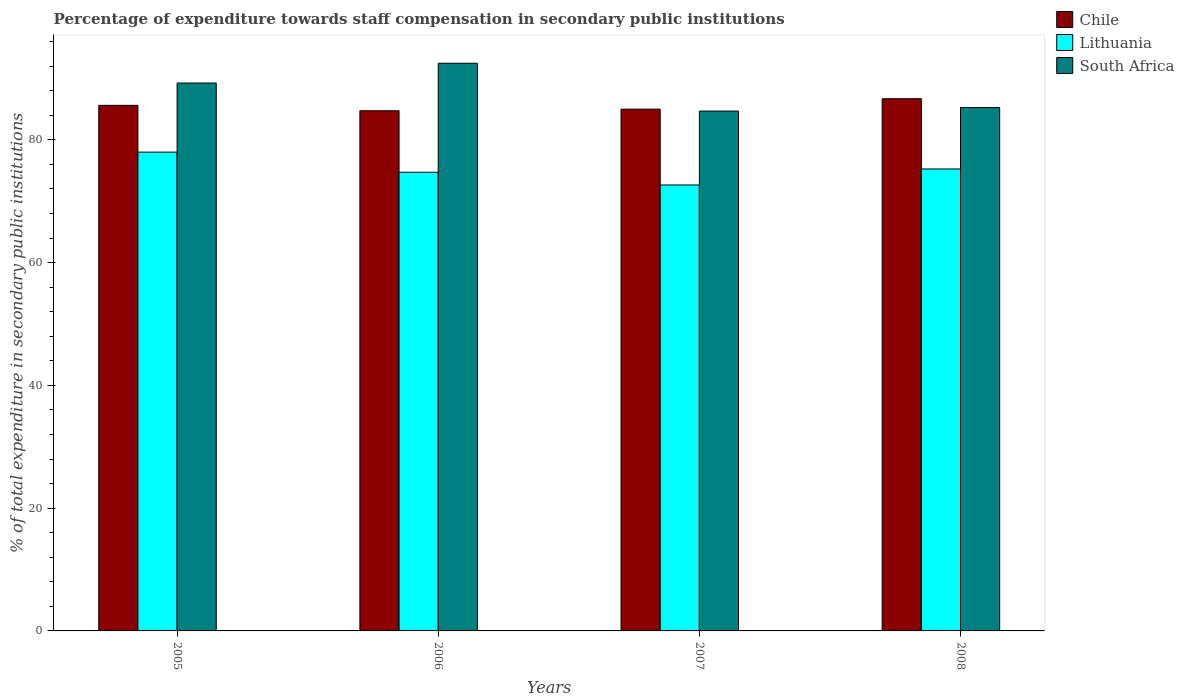Are the number of bars on each tick of the X-axis equal?
Offer a terse response. Yes. How many bars are there on the 3rd tick from the left?
Offer a terse response. 3. In how many cases, is the number of bars for a given year not equal to the number of legend labels?
Keep it short and to the point. 0. What is the percentage of expenditure towards staff compensation in South Africa in 2005?
Offer a very short reply. 89.25. Across all years, what is the maximum percentage of expenditure towards staff compensation in South Africa?
Ensure brevity in your answer.  92.47. Across all years, what is the minimum percentage of expenditure towards staff compensation in South Africa?
Your answer should be compact. 84.68. In which year was the percentage of expenditure towards staff compensation in Chile minimum?
Offer a very short reply. 2006. What is the total percentage of expenditure towards staff compensation in South Africa in the graph?
Give a very brief answer. 351.65. What is the difference between the percentage of expenditure towards staff compensation in Lithuania in 2005 and that in 2006?
Keep it short and to the point. 3.28. What is the difference between the percentage of expenditure towards staff compensation in Lithuania in 2008 and the percentage of expenditure towards staff compensation in Chile in 2005?
Offer a very short reply. -10.36. What is the average percentage of expenditure towards staff compensation in South Africa per year?
Offer a very short reply. 87.91. In the year 2005, what is the difference between the percentage of expenditure towards staff compensation in Lithuania and percentage of expenditure towards staff compensation in South Africa?
Keep it short and to the point. -11.26. What is the ratio of the percentage of expenditure towards staff compensation in Chile in 2006 to that in 2007?
Offer a very short reply. 1. Is the difference between the percentage of expenditure towards staff compensation in Lithuania in 2006 and 2008 greater than the difference between the percentage of expenditure towards staff compensation in South Africa in 2006 and 2008?
Your answer should be compact. No. What is the difference between the highest and the second highest percentage of expenditure towards staff compensation in Lithuania?
Make the answer very short. 2.74. What is the difference between the highest and the lowest percentage of expenditure towards staff compensation in Lithuania?
Provide a short and direct response. 5.35. In how many years, is the percentage of expenditure towards staff compensation in South Africa greater than the average percentage of expenditure towards staff compensation in South Africa taken over all years?
Your response must be concise. 2. Is the sum of the percentage of expenditure towards staff compensation in South Africa in 2005 and 2006 greater than the maximum percentage of expenditure towards staff compensation in Chile across all years?
Offer a very short reply. Yes. What does the 2nd bar from the left in 2008 represents?
Your answer should be compact. Lithuania. What does the 1st bar from the right in 2008 represents?
Your answer should be very brief. South Africa. How many bars are there?
Provide a succinct answer. 12. Are all the bars in the graph horizontal?
Ensure brevity in your answer.  No. What is the difference between two consecutive major ticks on the Y-axis?
Ensure brevity in your answer.  20. Does the graph contain any zero values?
Keep it short and to the point. No. Where does the legend appear in the graph?
Ensure brevity in your answer.  Top right. What is the title of the graph?
Offer a very short reply. Percentage of expenditure towards staff compensation in secondary public institutions. Does "Papua New Guinea" appear as one of the legend labels in the graph?
Offer a very short reply. No. What is the label or title of the X-axis?
Make the answer very short. Years. What is the label or title of the Y-axis?
Offer a very short reply. % of total expenditure in secondary public institutions. What is the % of total expenditure in secondary public institutions of Chile in 2005?
Your response must be concise. 85.61. What is the % of total expenditure in secondary public institutions of Lithuania in 2005?
Give a very brief answer. 77.99. What is the % of total expenditure in secondary public institutions of South Africa in 2005?
Give a very brief answer. 89.25. What is the % of total expenditure in secondary public institutions of Chile in 2006?
Provide a short and direct response. 84.73. What is the % of total expenditure in secondary public institutions in Lithuania in 2006?
Your answer should be very brief. 74.71. What is the % of total expenditure in secondary public institutions of South Africa in 2006?
Keep it short and to the point. 92.47. What is the % of total expenditure in secondary public institutions in Chile in 2007?
Provide a succinct answer. 84.99. What is the % of total expenditure in secondary public institutions of Lithuania in 2007?
Give a very brief answer. 72.64. What is the % of total expenditure in secondary public institutions of South Africa in 2007?
Give a very brief answer. 84.68. What is the % of total expenditure in secondary public institutions in Chile in 2008?
Provide a short and direct response. 86.69. What is the % of total expenditure in secondary public institutions of Lithuania in 2008?
Give a very brief answer. 75.25. What is the % of total expenditure in secondary public institutions in South Africa in 2008?
Your answer should be very brief. 85.25. Across all years, what is the maximum % of total expenditure in secondary public institutions of Chile?
Make the answer very short. 86.69. Across all years, what is the maximum % of total expenditure in secondary public institutions in Lithuania?
Provide a succinct answer. 77.99. Across all years, what is the maximum % of total expenditure in secondary public institutions of South Africa?
Give a very brief answer. 92.47. Across all years, what is the minimum % of total expenditure in secondary public institutions in Chile?
Your answer should be very brief. 84.73. Across all years, what is the minimum % of total expenditure in secondary public institutions of Lithuania?
Provide a succinct answer. 72.64. Across all years, what is the minimum % of total expenditure in secondary public institutions in South Africa?
Your answer should be compact. 84.68. What is the total % of total expenditure in secondary public institutions in Chile in the graph?
Offer a terse response. 342.03. What is the total % of total expenditure in secondary public institutions in Lithuania in the graph?
Offer a very short reply. 300.6. What is the total % of total expenditure in secondary public institutions of South Africa in the graph?
Keep it short and to the point. 351.65. What is the difference between the % of total expenditure in secondary public institutions of Chile in 2005 and that in 2006?
Your answer should be compact. 0.88. What is the difference between the % of total expenditure in secondary public institutions of Lithuania in 2005 and that in 2006?
Offer a terse response. 3.28. What is the difference between the % of total expenditure in secondary public institutions in South Africa in 2005 and that in 2006?
Make the answer very short. -3.22. What is the difference between the % of total expenditure in secondary public institutions of Chile in 2005 and that in 2007?
Give a very brief answer. 0.62. What is the difference between the % of total expenditure in secondary public institutions of Lithuania in 2005 and that in 2007?
Offer a terse response. 5.35. What is the difference between the % of total expenditure in secondary public institutions of South Africa in 2005 and that in 2007?
Provide a succinct answer. 4.57. What is the difference between the % of total expenditure in secondary public institutions of Chile in 2005 and that in 2008?
Offer a very short reply. -1.08. What is the difference between the % of total expenditure in secondary public institutions of Lithuania in 2005 and that in 2008?
Your response must be concise. 2.74. What is the difference between the % of total expenditure in secondary public institutions of South Africa in 2005 and that in 2008?
Keep it short and to the point. 4. What is the difference between the % of total expenditure in secondary public institutions of Chile in 2006 and that in 2007?
Your answer should be very brief. -0.26. What is the difference between the % of total expenditure in secondary public institutions of Lithuania in 2006 and that in 2007?
Make the answer very short. 2.07. What is the difference between the % of total expenditure in secondary public institutions of South Africa in 2006 and that in 2007?
Your answer should be very brief. 7.79. What is the difference between the % of total expenditure in secondary public institutions in Chile in 2006 and that in 2008?
Your answer should be very brief. -1.96. What is the difference between the % of total expenditure in secondary public institutions in Lithuania in 2006 and that in 2008?
Offer a terse response. -0.54. What is the difference between the % of total expenditure in secondary public institutions of South Africa in 2006 and that in 2008?
Keep it short and to the point. 7.22. What is the difference between the % of total expenditure in secondary public institutions of Chile in 2007 and that in 2008?
Your answer should be compact. -1.7. What is the difference between the % of total expenditure in secondary public institutions in Lithuania in 2007 and that in 2008?
Your answer should be compact. -2.61. What is the difference between the % of total expenditure in secondary public institutions of South Africa in 2007 and that in 2008?
Your answer should be very brief. -0.57. What is the difference between the % of total expenditure in secondary public institutions in Chile in 2005 and the % of total expenditure in secondary public institutions in Lithuania in 2006?
Your answer should be compact. 10.9. What is the difference between the % of total expenditure in secondary public institutions in Chile in 2005 and the % of total expenditure in secondary public institutions in South Africa in 2006?
Your response must be concise. -6.86. What is the difference between the % of total expenditure in secondary public institutions of Lithuania in 2005 and the % of total expenditure in secondary public institutions of South Africa in 2006?
Ensure brevity in your answer.  -14.47. What is the difference between the % of total expenditure in secondary public institutions of Chile in 2005 and the % of total expenditure in secondary public institutions of Lithuania in 2007?
Ensure brevity in your answer.  12.97. What is the difference between the % of total expenditure in secondary public institutions in Chile in 2005 and the % of total expenditure in secondary public institutions in South Africa in 2007?
Make the answer very short. 0.93. What is the difference between the % of total expenditure in secondary public institutions of Lithuania in 2005 and the % of total expenditure in secondary public institutions of South Africa in 2007?
Ensure brevity in your answer.  -6.69. What is the difference between the % of total expenditure in secondary public institutions in Chile in 2005 and the % of total expenditure in secondary public institutions in Lithuania in 2008?
Ensure brevity in your answer.  10.36. What is the difference between the % of total expenditure in secondary public institutions in Chile in 2005 and the % of total expenditure in secondary public institutions in South Africa in 2008?
Make the answer very short. 0.36. What is the difference between the % of total expenditure in secondary public institutions in Lithuania in 2005 and the % of total expenditure in secondary public institutions in South Africa in 2008?
Your answer should be very brief. -7.26. What is the difference between the % of total expenditure in secondary public institutions of Chile in 2006 and the % of total expenditure in secondary public institutions of Lithuania in 2007?
Ensure brevity in your answer.  12.09. What is the difference between the % of total expenditure in secondary public institutions of Chile in 2006 and the % of total expenditure in secondary public institutions of South Africa in 2007?
Your response must be concise. 0.05. What is the difference between the % of total expenditure in secondary public institutions of Lithuania in 2006 and the % of total expenditure in secondary public institutions of South Africa in 2007?
Provide a short and direct response. -9.97. What is the difference between the % of total expenditure in secondary public institutions of Chile in 2006 and the % of total expenditure in secondary public institutions of Lithuania in 2008?
Keep it short and to the point. 9.48. What is the difference between the % of total expenditure in secondary public institutions of Chile in 2006 and the % of total expenditure in secondary public institutions of South Africa in 2008?
Offer a very short reply. -0.52. What is the difference between the % of total expenditure in secondary public institutions in Lithuania in 2006 and the % of total expenditure in secondary public institutions in South Africa in 2008?
Make the answer very short. -10.54. What is the difference between the % of total expenditure in secondary public institutions in Chile in 2007 and the % of total expenditure in secondary public institutions in Lithuania in 2008?
Make the answer very short. 9.74. What is the difference between the % of total expenditure in secondary public institutions of Chile in 2007 and the % of total expenditure in secondary public institutions of South Africa in 2008?
Ensure brevity in your answer.  -0.26. What is the difference between the % of total expenditure in secondary public institutions of Lithuania in 2007 and the % of total expenditure in secondary public institutions of South Africa in 2008?
Ensure brevity in your answer.  -12.61. What is the average % of total expenditure in secondary public institutions in Chile per year?
Offer a very short reply. 85.51. What is the average % of total expenditure in secondary public institutions of Lithuania per year?
Your answer should be compact. 75.15. What is the average % of total expenditure in secondary public institutions of South Africa per year?
Make the answer very short. 87.91. In the year 2005, what is the difference between the % of total expenditure in secondary public institutions of Chile and % of total expenditure in secondary public institutions of Lithuania?
Keep it short and to the point. 7.62. In the year 2005, what is the difference between the % of total expenditure in secondary public institutions of Chile and % of total expenditure in secondary public institutions of South Africa?
Provide a short and direct response. -3.64. In the year 2005, what is the difference between the % of total expenditure in secondary public institutions in Lithuania and % of total expenditure in secondary public institutions in South Africa?
Your response must be concise. -11.26. In the year 2006, what is the difference between the % of total expenditure in secondary public institutions in Chile and % of total expenditure in secondary public institutions in Lithuania?
Make the answer very short. 10.02. In the year 2006, what is the difference between the % of total expenditure in secondary public institutions of Chile and % of total expenditure in secondary public institutions of South Africa?
Provide a short and direct response. -7.74. In the year 2006, what is the difference between the % of total expenditure in secondary public institutions in Lithuania and % of total expenditure in secondary public institutions in South Africa?
Your answer should be very brief. -17.75. In the year 2007, what is the difference between the % of total expenditure in secondary public institutions of Chile and % of total expenditure in secondary public institutions of Lithuania?
Your answer should be compact. 12.35. In the year 2007, what is the difference between the % of total expenditure in secondary public institutions in Chile and % of total expenditure in secondary public institutions in South Africa?
Make the answer very short. 0.31. In the year 2007, what is the difference between the % of total expenditure in secondary public institutions of Lithuania and % of total expenditure in secondary public institutions of South Africa?
Your response must be concise. -12.04. In the year 2008, what is the difference between the % of total expenditure in secondary public institutions in Chile and % of total expenditure in secondary public institutions in Lithuania?
Make the answer very short. 11.44. In the year 2008, what is the difference between the % of total expenditure in secondary public institutions in Chile and % of total expenditure in secondary public institutions in South Africa?
Offer a terse response. 1.44. In the year 2008, what is the difference between the % of total expenditure in secondary public institutions of Lithuania and % of total expenditure in secondary public institutions of South Africa?
Provide a short and direct response. -10. What is the ratio of the % of total expenditure in secondary public institutions in Chile in 2005 to that in 2006?
Offer a terse response. 1.01. What is the ratio of the % of total expenditure in secondary public institutions of Lithuania in 2005 to that in 2006?
Offer a very short reply. 1.04. What is the ratio of the % of total expenditure in secondary public institutions of South Africa in 2005 to that in 2006?
Ensure brevity in your answer.  0.97. What is the ratio of the % of total expenditure in secondary public institutions of Chile in 2005 to that in 2007?
Provide a short and direct response. 1.01. What is the ratio of the % of total expenditure in secondary public institutions of Lithuania in 2005 to that in 2007?
Ensure brevity in your answer.  1.07. What is the ratio of the % of total expenditure in secondary public institutions of South Africa in 2005 to that in 2007?
Give a very brief answer. 1.05. What is the ratio of the % of total expenditure in secondary public institutions in Chile in 2005 to that in 2008?
Offer a terse response. 0.99. What is the ratio of the % of total expenditure in secondary public institutions of Lithuania in 2005 to that in 2008?
Provide a succinct answer. 1.04. What is the ratio of the % of total expenditure in secondary public institutions of South Africa in 2005 to that in 2008?
Your response must be concise. 1.05. What is the ratio of the % of total expenditure in secondary public institutions of Lithuania in 2006 to that in 2007?
Give a very brief answer. 1.03. What is the ratio of the % of total expenditure in secondary public institutions in South Africa in 2006 to that in 2007?
Make the answer very short. 1.09. What is the ratio of the % of total expenditure in secondary public institutions in Chile in 2006 to that in 2008?
Ensure brevity in your answer.  0.98. What is the ratio of the % of total expenditure in secondary public institutions of Lithuania in 2006 to that in 2008?
Keep it short and to the point. 0.99. What is the ratio of the % of total expenditure in secondary public institutions in South Africa in 2006 to that in 2008?
Offer a terse response. 1.08. What is the ratio of the % of total expenditure in secondary public institutions of Chile in 2007 to that in 2008?
Keep it short and to the point. 0.98. What is the ratio of the % of total expenditure in secondary public institutions of Lithuania in 2007 to that in 2008?
Your answer should be compact. 0.97. What is the ratio of the % of total expenditure in secondary public institutions in South Africa in 2007 to that in 2008?
Offer a very short reply. 0.99. What is the difference between the highest and the second highest % of total expenditure in secondary public institutions in Chile?
Your answer should be very brief. 1.08. What is the difference between the highest and the second highest % of total expenditure in secondary public institutions of Lithuania?
Keep it short and to the point. 2.74. What is the difference between the highest and the second highest % of total expenditure in secondary public institutions of South Africa?
Keep it short and to the point. 3.22. What is the difference between the highest and the lowest % of total expenditure in secondary public institutions of Chile?
Provide a succinct answer. 1.96. What is the difference between the highest and the lowest % of total expenditure in secondary public institutions of Lithuania?
Provide a succinct answer. 5.35. What is the difference between the highest and the lowest % of total expenditure in secondary public institutions of South Africa?
Your response must be concise. 7.79. 